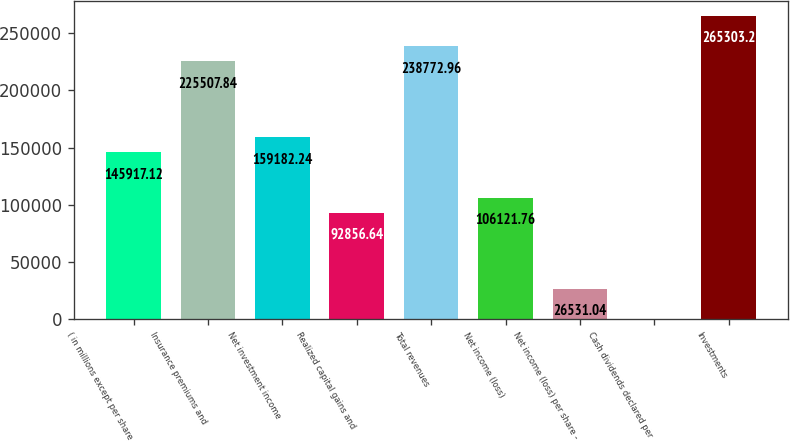Convert chart to OTSL. <chart><loc_0><loc_0><loc_500><loc_500><bar_chart><fcel>( in millions except per share<fcel>Insurance premiums and<fcel>Net investment income<fcel>Realized capital gains and<fcel>Total revenues<fcel>Net income (loss)<fcel>Net income (loss) per share -<fcel>Cash dividends declared per<fcel>Investments<nl><fcel>145917<fcel>225508<fcel>159182<fcel>92856.6<fcel>238773<fcel>106122<fcel>26531<fcel>0.8<fcel>265303<nl></chart> 